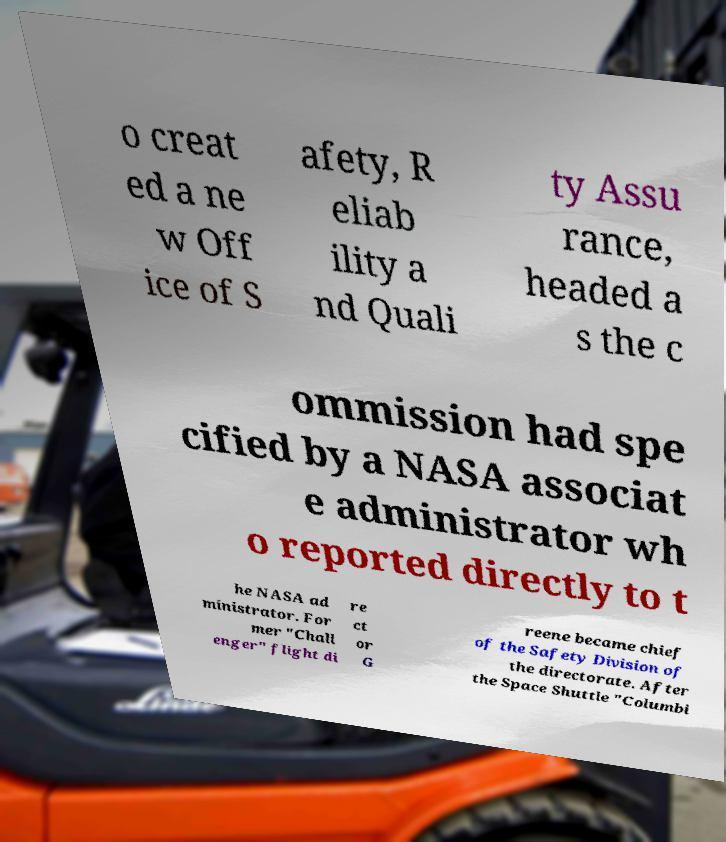There's text embedded in this image that I need extracted. Can you transcribe it verbatim? o creat ed a ne w Off ice of S afety, R eliab ility a nd Quali ty Assu rance, headed a s the c ommission had spe cified by a NASA associat e administrator wh o reported directly to t he NASA ad ministrator. For mer "Chall enger" flight di re ct or G reene became chief of the Safety Division of the directorate. After the Space Shuttle "Columbi 